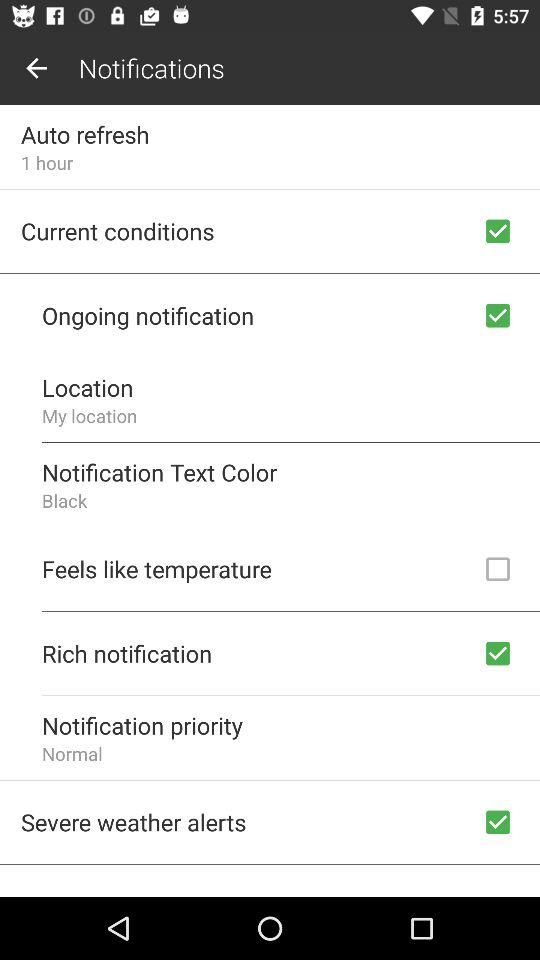What is the setting for "Auto refresh" time? The setting for "Auto refresh" time is 1 hour. 